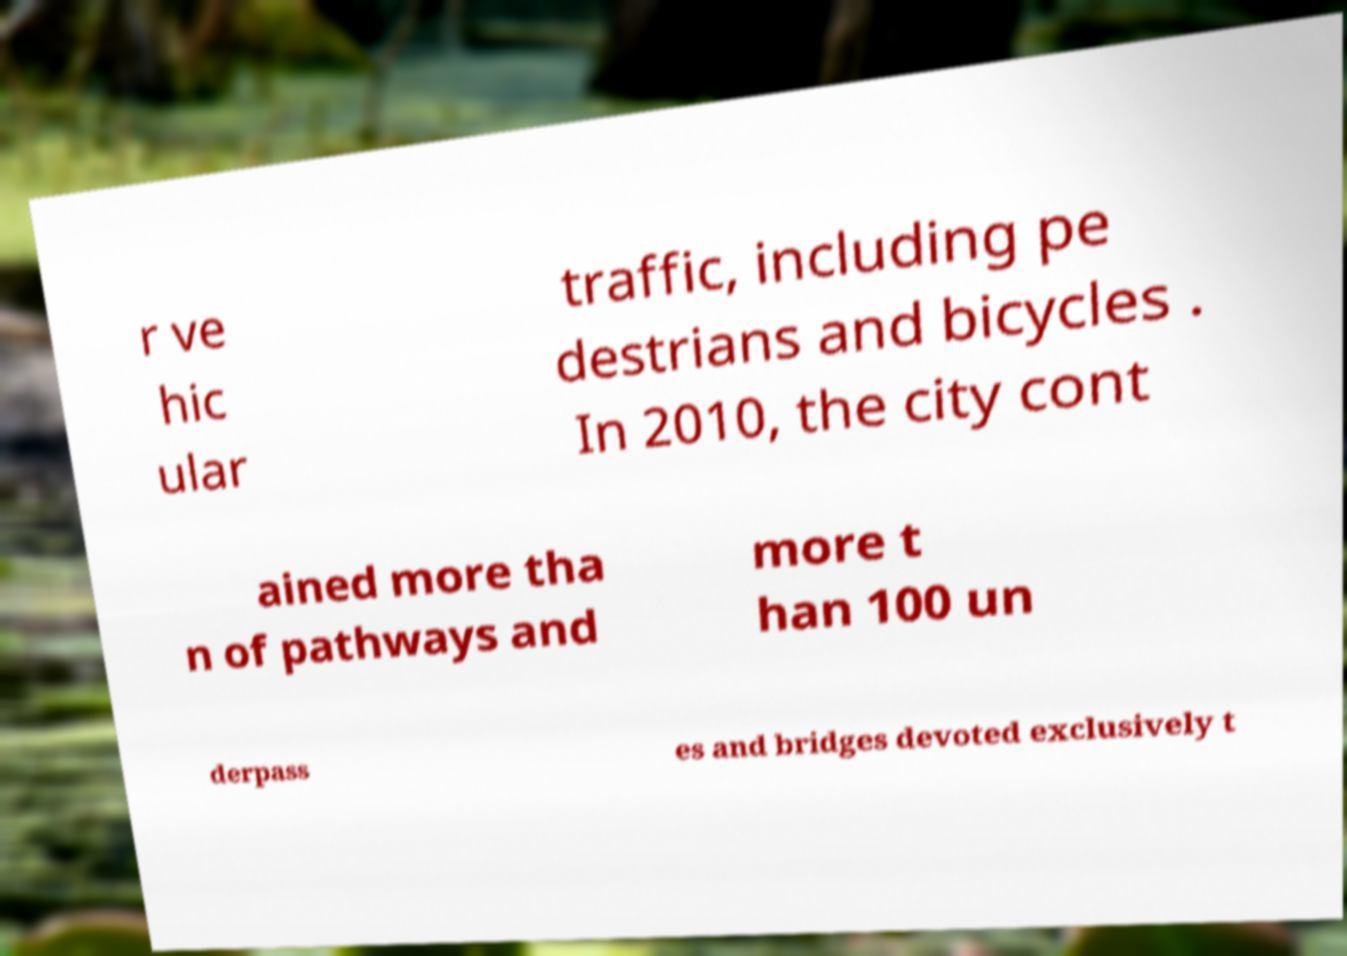Please read and relay the text visible in this image. What does it say? r ve hic ular traffic, including pe destrians and bicycles . In 2010, the city cont ained more tha n of pathways and more t han 100 un derpass es and bridges devoted exclusively t 